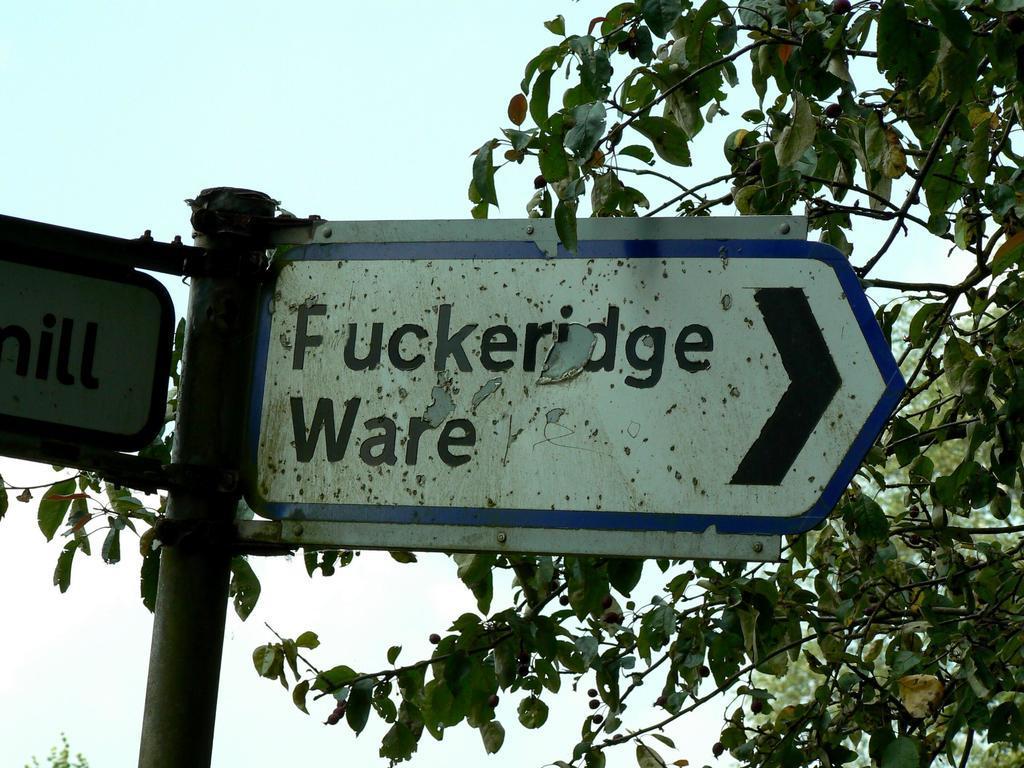Could you give a brief overview of what you see in this image? This picture is taken from the outside of the city. In this image, on the right side, we can see some trees. On the left side, we can see a pole and board, on the board, we can see some text written on it. In the background, we can see a sky which is a bit cloudy. 